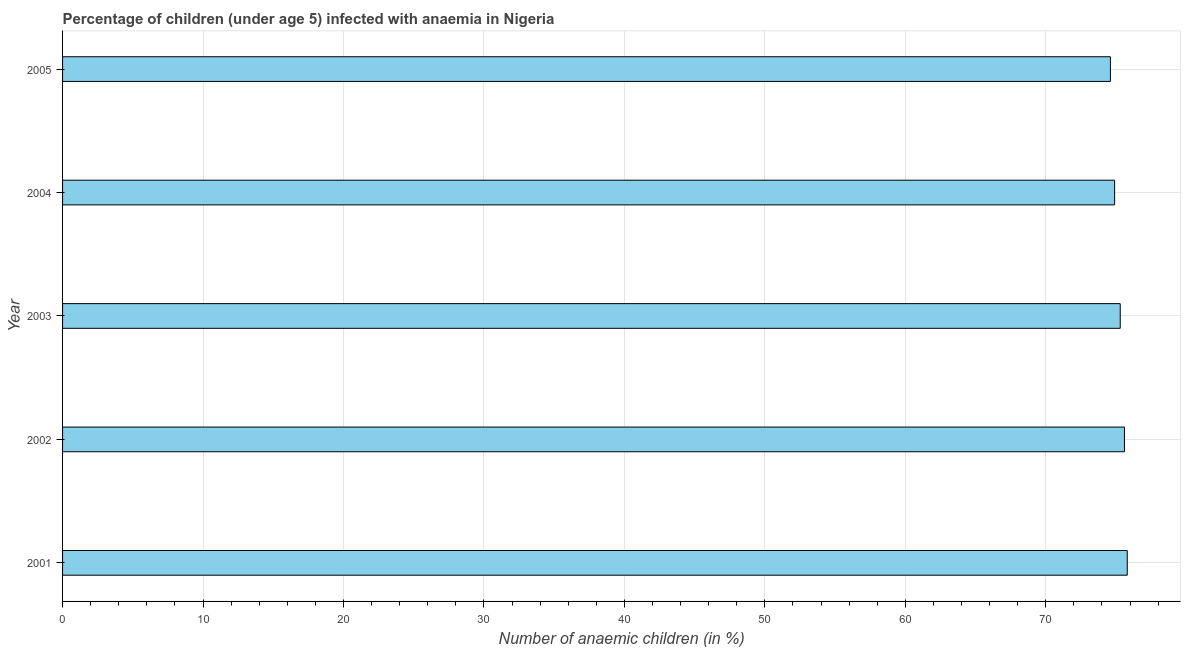Does the graph contain any zero values?
Your answer should be very brief. No. Does the graph contain grids?
Provide a succinct answer. Yes. What is the title of the graph?
Your response must be concise. Percentage of children (under age 5) infected with anaemia in Nigeria. What is the label or title of the X-axis?
Your response must be concise. Number of anaemic children (in %). What is the number of anaemic children in 2004?
Your answer should be very brief. 74.9. Across all years, what is the maximum number of anaemic children?
Your answer should be compact. 75.8. Across all years, what is the minimum number of anaemic children?
Make the answer very short. 74.6. In which year was the number of anaemic children minimum?
Ensure brevity in your answer.  2005. What is the sum of the number of anaemic children?
Offer a very short reply. 376.2. What is the difference between the number of anaemic children in 2001 and 2002?
Provide a succinct answer. 0.2. What is the average number of anaemic children per year?
Provide a short and direct response. 75.24. What is the median number of anaemic children?
Provide a short and direct response. 75.3. In how many years, is the number of anaemic children greater than 54 %?
Ensure brevity in your answer.  5. What is the ratio of the number of anaemic children in 2001 to that in 2005?
Your answer should be compact. 1.02. What is the difference between the highest and the second highest number of anaemic children?
Ensure brevity in your answer.  0.2. Is the sum of the number of anaemic children in 2001 and 2002 greater than the maximum number of anaemic children across all years?
Offer a terse response. Yes. In how many years, is the number of anaemic children greater than the average number of anaemic children taken over all years?
Your answer should be compact. 3. What is the difference between two consecutive major ticks on the X-axis?
Your answer should be very brief. 10. Are the values on the major ticks of X-axis written in scientific E-notation?
Provide a short and direct response. No. What is the Number of anaemic children (in %) in 2001?
Make the answer very short. 75.8. What is the Number of anaemic children (in %) in 2002?
Your answer should be very brief. 75.6. What is the Number of anaemic children (in %) of 2003?
Make the answer very short. 75.3. What is the Number of anaemic children (in %) in 2004?
Provide a succinct answer. 74.9. What is the Number of anaemic children (in %) of 2005?
Your answer should be compact. 74.6. What is the difference between the Number of anaemic children (in %) in 2001 and 2002?
Ensure brevity in your answer.  0.2. What is the difference between the Number of anaemic children (in %) in 2001 and 2004?
Keep it short and to the point. 0.9. What is the difference between the Number of anaemic children (in %) in 2002 and 2005?
Provide a succinct answer. 1. What is the ratio of the Number of anaemic children (in %) in 2002 to that in 2004?
Keep it short and to the point. 1.01. What is the ratio of the Number of anaemic children (in %) in 2002 to that in 2005?
Your answer should be very brief. 1.01. What is the ratio of the Number of anaemic children (in %) in 2003 to that in 2004?
Provide a short and direct response. 1. What is the ratio of the Number of anaemic children (in %) in 2003 to that in 2005?
Your answer should be very brief. 1.01. What is the ratio of the Number of anaemic children (in %) in 2004 to that in 2005?
Your response must be concise. 1. 